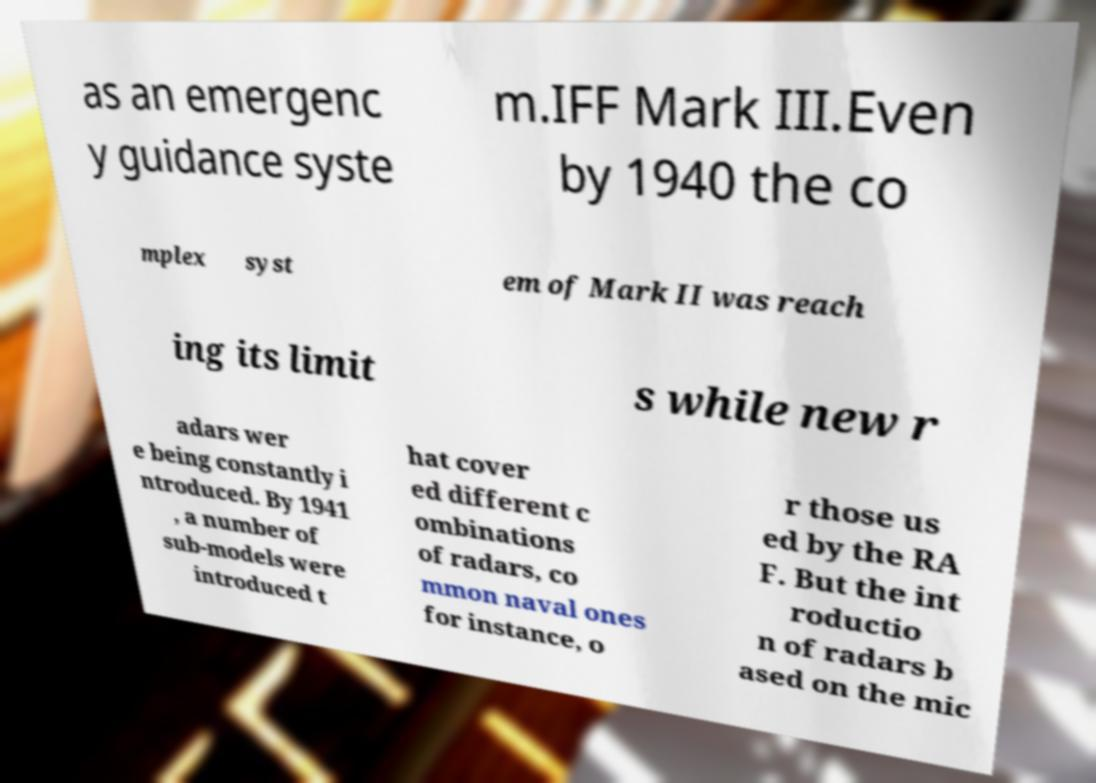Could you extract and type out the text from this image? as an emergenc y guidance syste m.IFF Mark III.Even by 1940 the co mplex syst em of Mark II was reach ing its limit s while new r adars wer e being constantly i ntroduced. By 1941 , a number of sub-models were introduced t hat cover ed different c ombinations of radars, co mmon naval ones for instance, o r those us ed by the RA F. But the int roductio n of radars b ased on the mic 